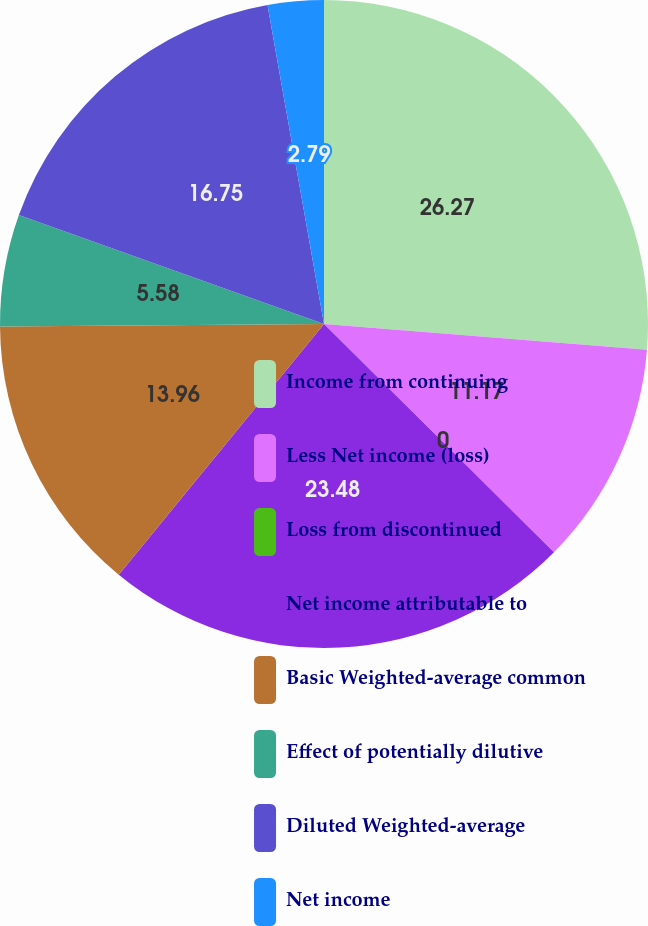<chart> <loc_0><loc_0><loc_500><loc_500><pie_chart><fcel>Income from continuing<fcel>Less Net income (loss)<fcel>Loss from discontinued<fcel>Net income attributable to<fcel>Basic Weighted-average common<fcel>Effect of potentially dilutive<fcel>Diluted Weighted-average<fcel>Net income<nl><fcel>26.27%<fcel>11.17%<fcel>0.0%<fcel>23.48%<fcel>13.96%<fcel>5.58%<fcel>16.75%<fcel>2.79%<nl></chart> 